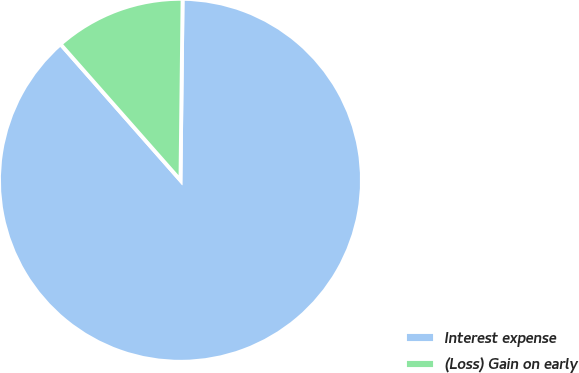<chart> <loc_0><loc_0><loc_500><loc_500><pie_chart><fcel>Interest expense<fcel>(Loss) Gain on early<nl><fcel>88.32%<fcel>11.68%<nl></chart> 